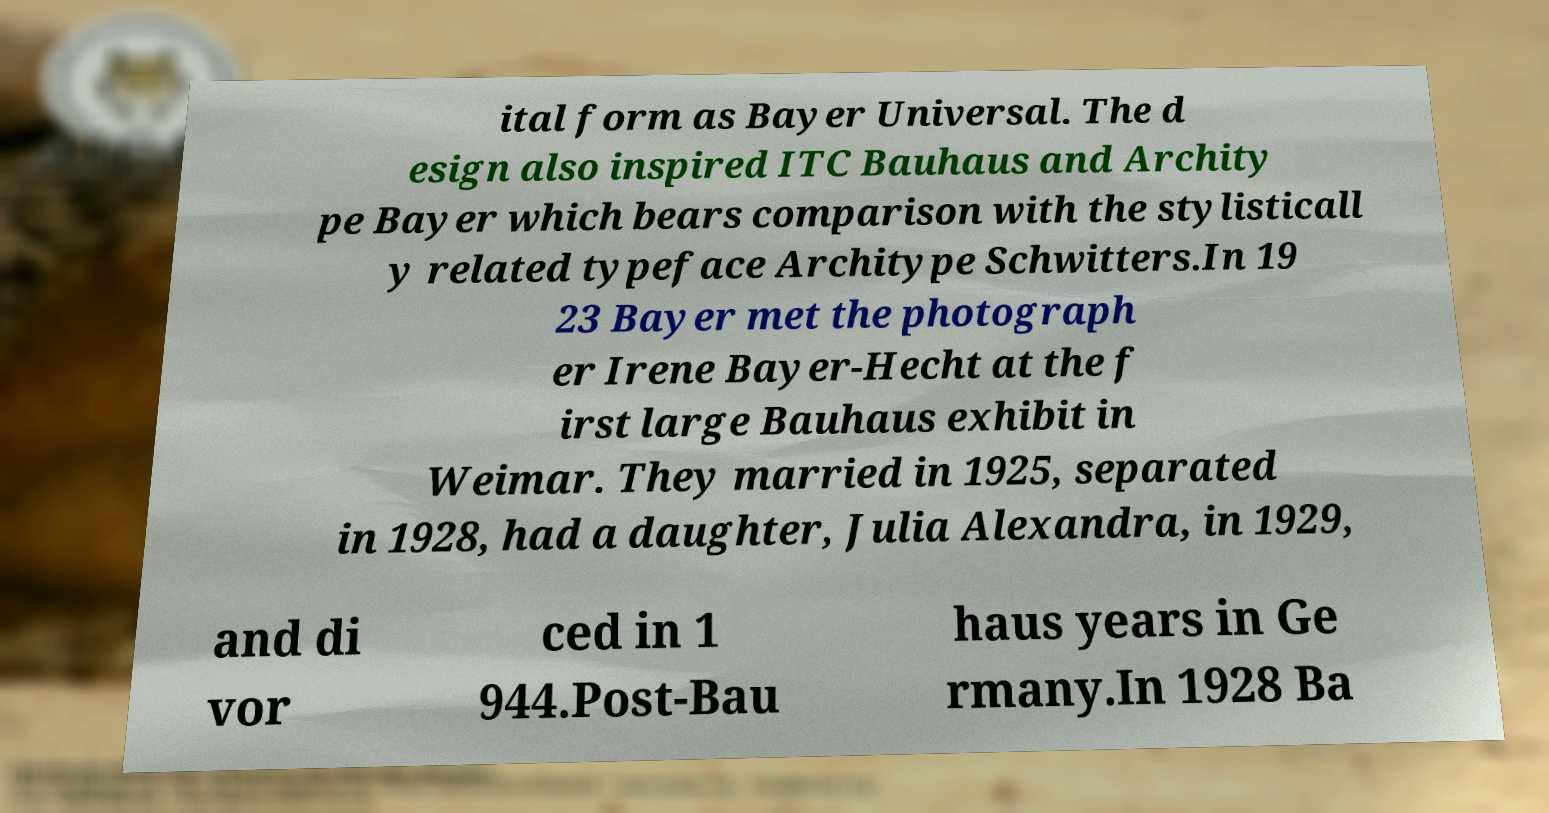Could you extract and type out the text from this image? ital form as Bayer Universal. The d esign also inspired ITC Bauhaus and Archity pe Bayer which bears comparison with the stylisticall y related typeface Architype Schwitters.In 19 23 Bayer met the photograph er Irene Bayer-Hecht at the f irst large Bauhaus exhibit in Weimar. They married in 1925, separated in 1928, had a daughter, Julia Alexandra, in 1929, and di vor ced in 1 944.Post-Bau haus years in Ge rmany.In 1928 Ba 